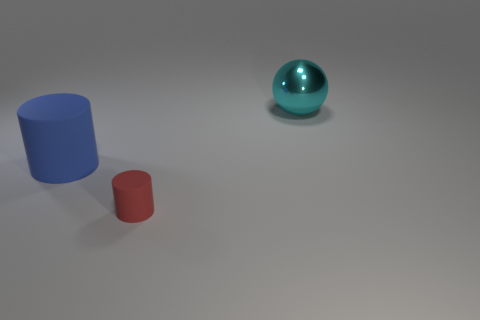Add 2 big gray matte objects. How many objects exist? 5 Subtract all balls. How many objects are left? 2 Subtract all large red metal cylinders. Subtract all small red matte objects. How many objects are left? 2 Add 1 big rubber cylinders. How many big rubber cylinders are left? 2 Add 3 cyan rubber cylinders. How many cyan rubber cylinders exist? 3 Subtract 0 yellow spheres. How many objects are left? 3 